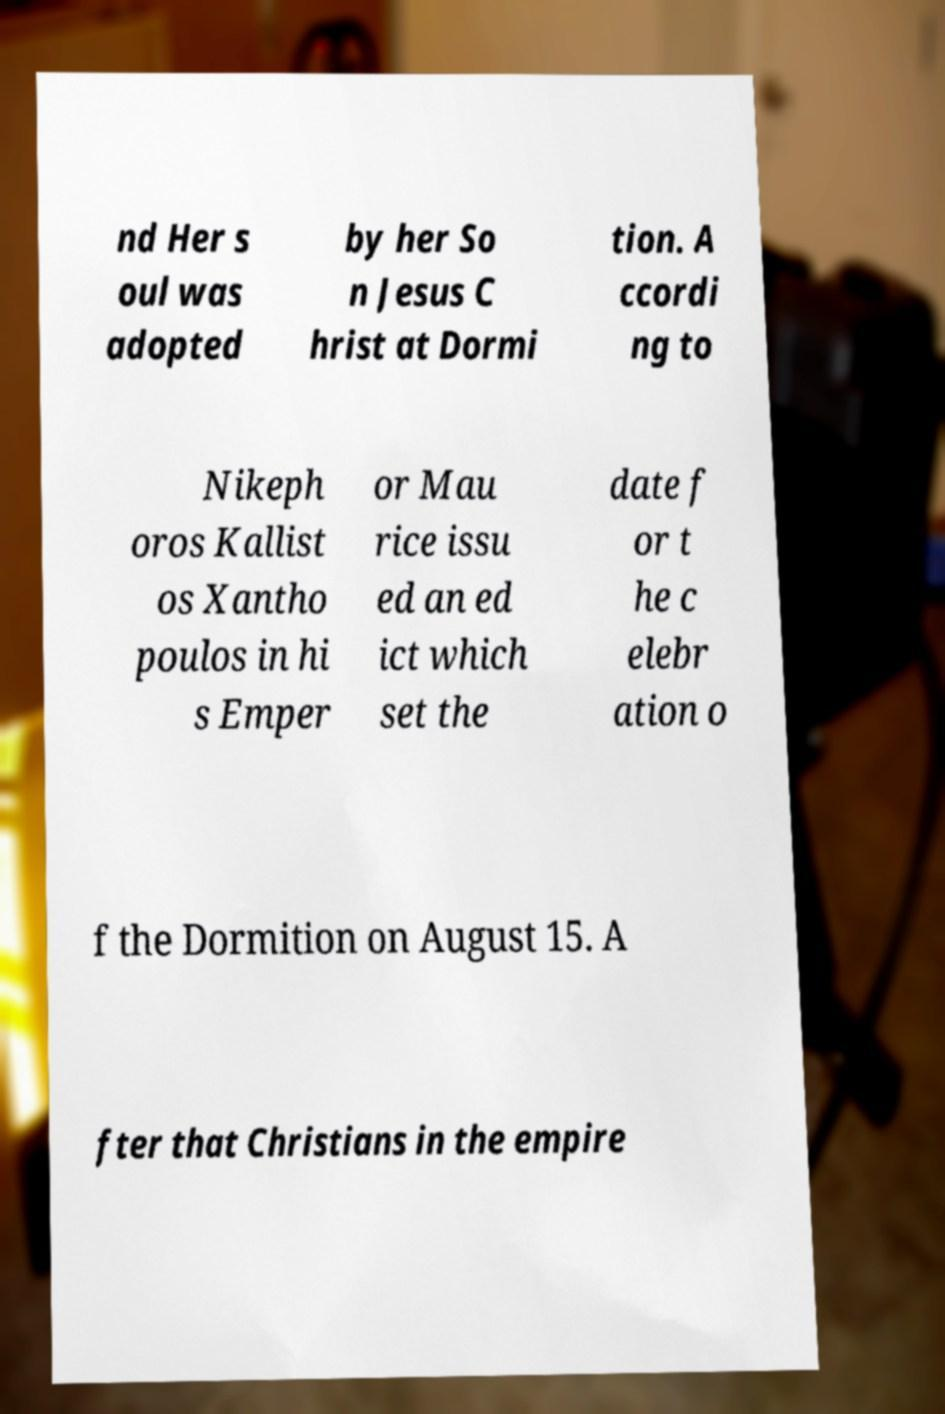What messages or text are displayed in this image? I need them in a readable, typed format. nd Her s oul was adopted by her So n Jesus C hrist at Dormi tion. A ccordi ng to Nikeph oros Kallist os Xantho poulos in hi s Emper or Mau rice issu ed an ed ict which set the date f or t he c elebr ation o f the Dormition on August 15. A fter that Christians in the empire 